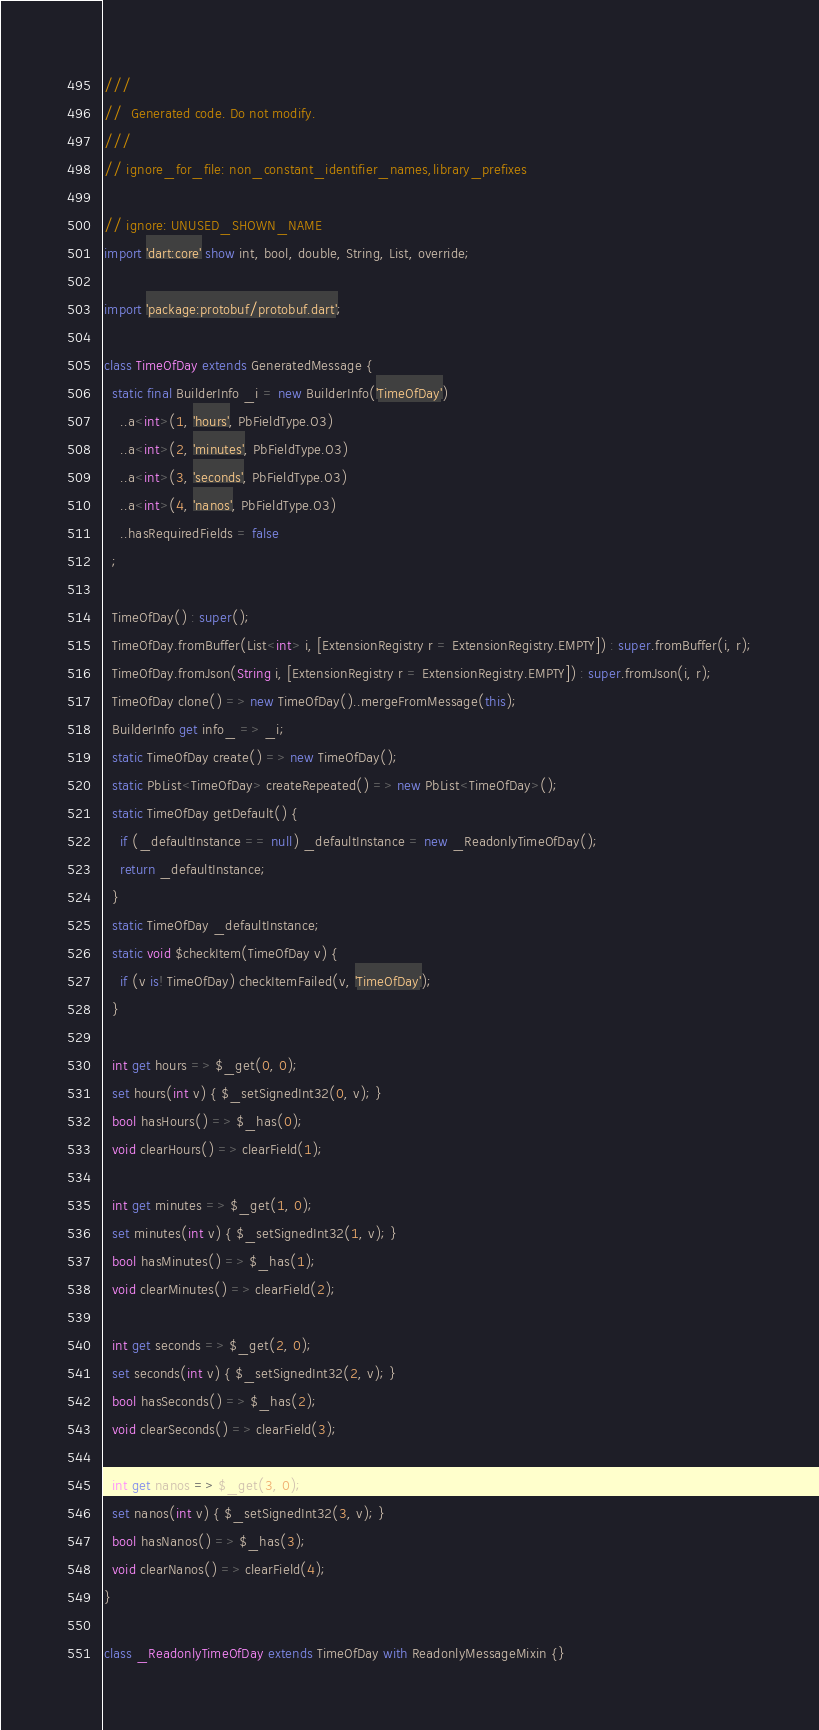<code> <loc_0><loc_0><loc_500><loc_500><_Dart_>///
//  Generated code. Do not modify.
///
// ignore_for_file: non_constant_identifier_names,library_prefixes

// ignore: UNUSED_SHOWN_NAME
import 'dart:core' show int, bool, double, String, List, override;

import 'package:protobuf/protobuf.dart';

class TimeOfDay extends GeneratedMessage {
  static final BuilderInfo _i = new BuilderInfo('TimeOfDay')
    ..a<int>(1, 'hours', PbFieldType.O3)
    ..a<int>(2, 'minutes', PbFieldType.O3)
    ..a<int>(3, 'seconds', PbFieldType.O3)
    ..a<int>(4, 'nanos', PbFieldType.O3)
    ..hasRequiredFields = false
  ;

  TimeOfDay() : super();
  TimeOfDay.fromBuffer(List<int> i, [ExtensionRegistry r = ExtensionRegistry.EMPTY]) : super.fromBuffer(i, r);
  TimeOfDay.fromJson(String i, [ExtensionRegistry r = ExtensionRegistry.EMPTY]) : super.fromJson(i, r);
  TimeOfDay clone() => new TimeOfDay()..mergeFromMessage(this);
  BuilderInfo get info_ => _i;
  static TimeOfDay create() => new TimeOfDay();
  static PbList<TimeOfDay> createRepeated() => new PbList<TimeOfDay>();
  static TimeOfDay getDefault() {
    if (_defaultInstance == null) _defaultInstance = new _ReadonlyTimeOfDay();
    return _defaultInstance;
  }
  static TimeOfDay _defaultInstance;
  static void $checkItem(TimeOfDay v) {
    if (v is! TimeOfDay) checkItemFailed(v, 'TimeOfDay');
  }

  int get hours => $_get(0, 0);
  set hours(int v) { $_setSignedInt32(0, v); }
  bool hasHours() => $_has(0);
  void clearHours() => clearField(1);

  int get minutes => $_get(1, 0);
  set minutes(int v) { $_setSignedInt32(1, v); }
  bool hasMinutes() => $_has(1);
  void clearMinutes() => clearField(2);

  int get seconds => $_get(2, 0);
  set seconds(int v) { $_setSignedInt32(2, v); }
  bool hasSeconds() => $_has(2);
  void clearSeconds() => clearField(3);

  int get nanos => $_get(3, 0);
  set nanos(int v) { $_setSignedInt32(3, v); }
  bool hasNanos() => $_has(3);
  void clearNanos() => clearField(4);
}

class _ReadonlyTimeOfDay extends TimeOfDay with ReadonlyMessageMixin {}

</code> 